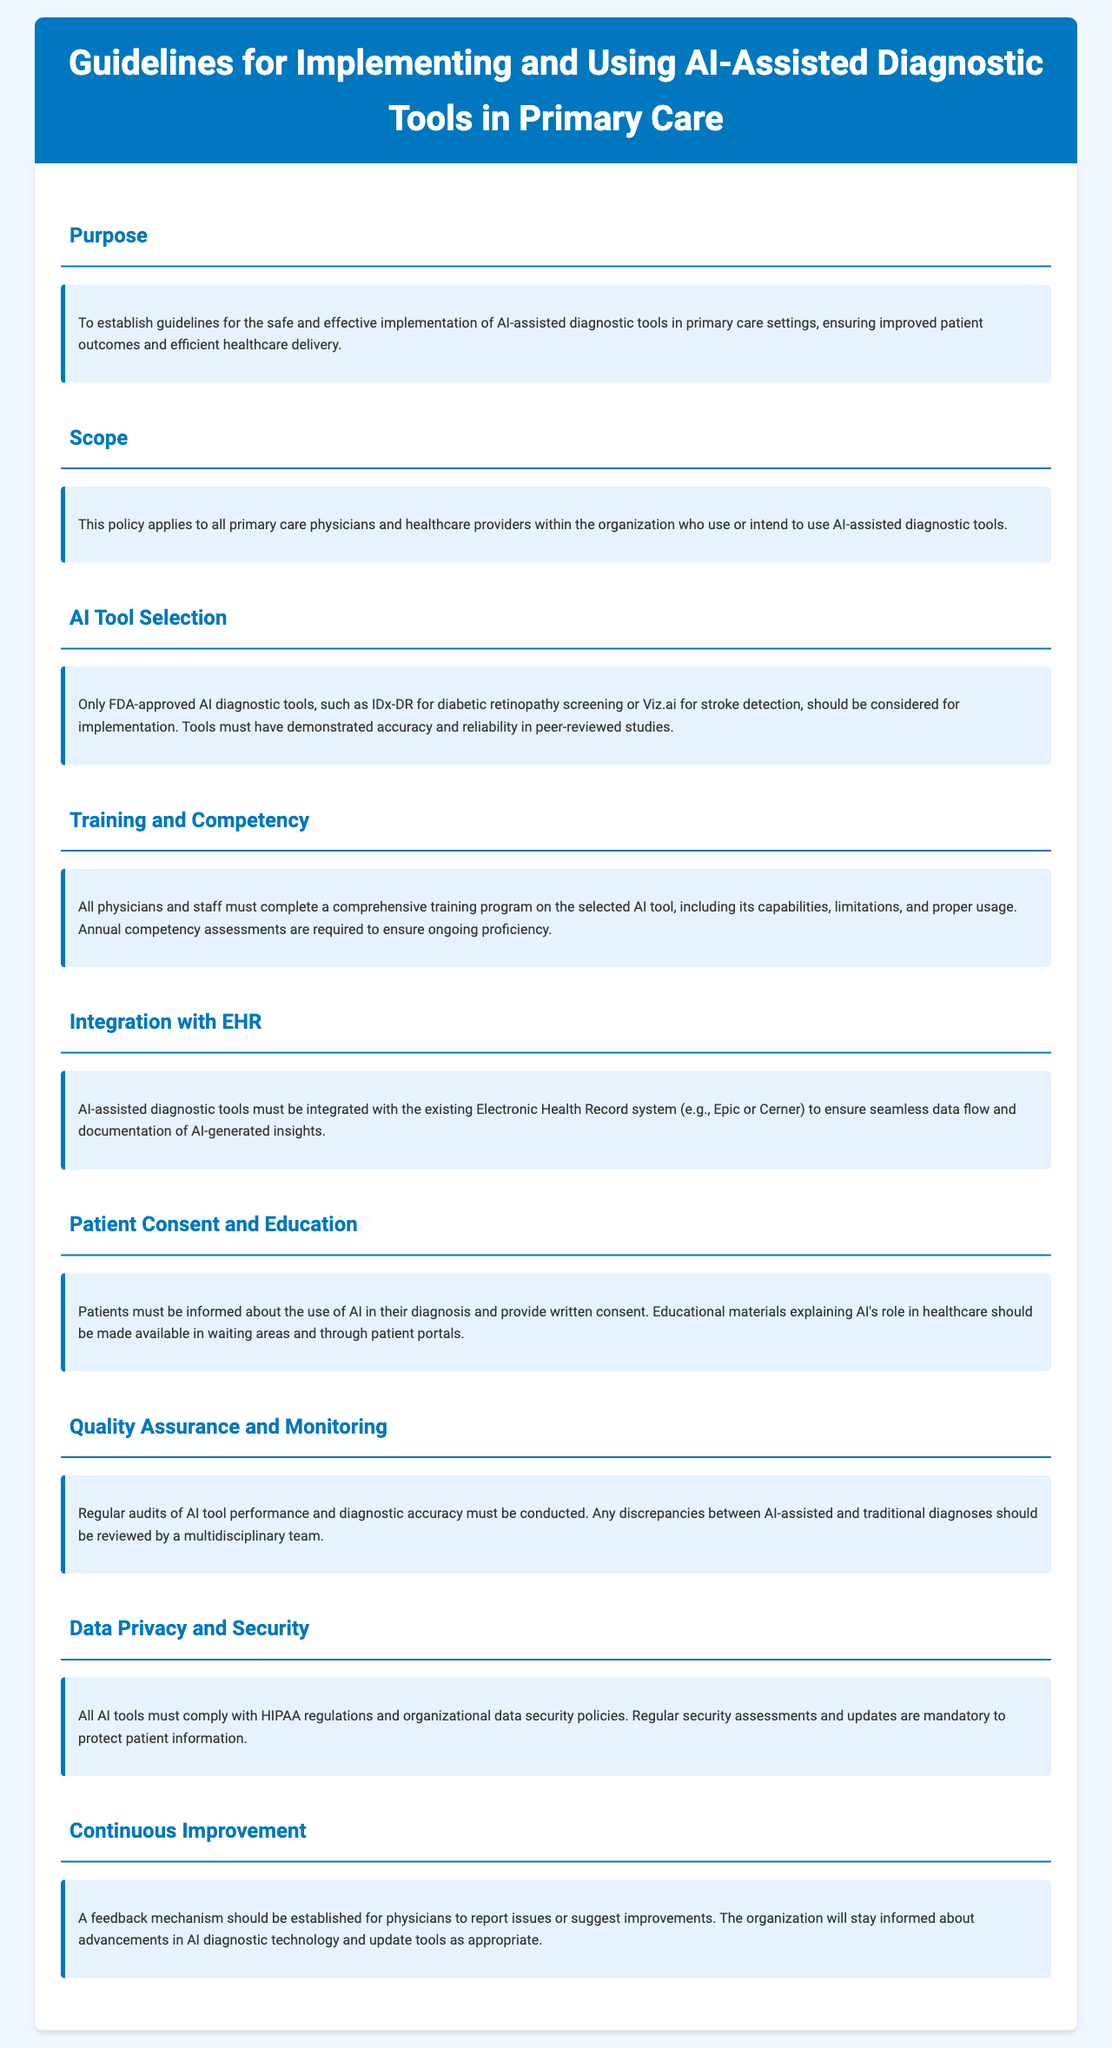What is the purpose of the guidelines? The purpose is to establish guidelines for the safe and effective implementation of AI-assisted diagnostic tools in primary care settings.
Answer: To establish guidelines for the safe and effective implementation of AI-assisted diagnostic tools in primary care settings Who must provide written consent? Patients must be informed about the use of AI in their diagnosis and provide written consent.
Answer: Patients What kind of tools should be considered for implementation? Only FDA-approved AI diagnostic tools should be considered for implementation.
Answer: FDA-approved AI diagnostic tools What is required for ongoing proficiency? Annual competency assessments are required to ensure ongoing proficiency.
Answer: Annual competency assessments What should be integrated with existing EHR systems? AI-assisted diagnostic tools must be integrated with the existing Electronic Health Record system.
Answer: AI-assisted diagnostic tools How often must audits be conducted? Regular audits of AI tool performance and diagnostic accuracy must be conducted.
Answer: Regularly What must all AI tools comply with? All AI tools must comply with HIPAA regulations and organizational data security policies.
Answer: HIPAA regulations What is required for physicians regarding training? All physicians and staff must complete a comprehensive training program on the selected AI tool.
Answer: Comprehensive training program What is established for continuous improvement? A feedback mechanism should be established for physicians to report issues or suggest improvements.
Answer: A feedback mechanism 